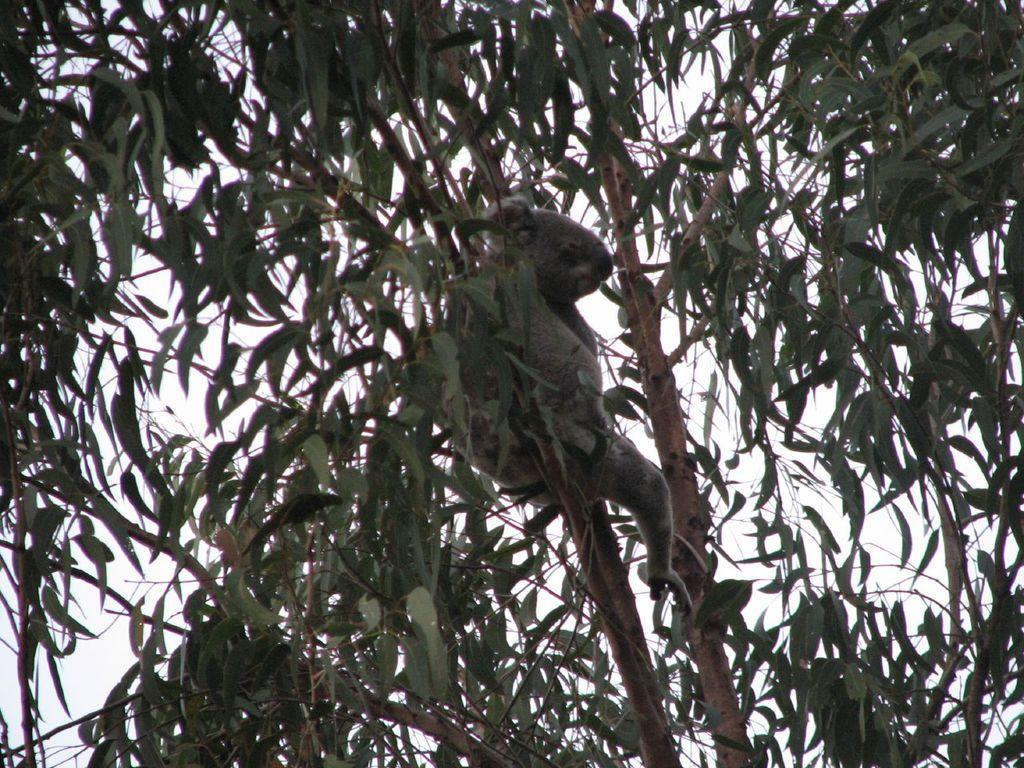What type of vegetation can be seen in the front of the image? There are leaves and branches in the front of the image. What else is present in the front of the image besides vegetation? There is an animal in the front of the image. What can be seen in the background of the image? Sky is visible in the background of the image. How many rifles can be seen in the image? There are no rifles present in the image. On which side of the image is the animal located? The provided facts do not specify the side of the image where the animal is located. 